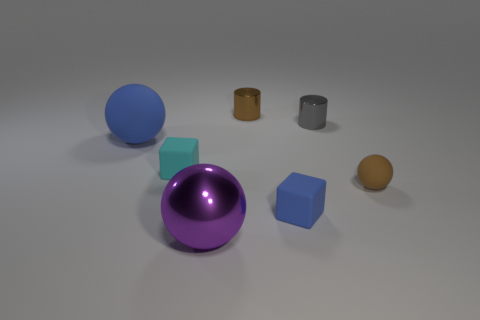What is the shape of the tiny thing in front of the ball that is on the right side of the gray metal cylinder?
Provide a short and direct response. Cube. What number of other things are the same shape as the large matte thing?
Offer a very short reply. 2. Are there any big purple shiny things right of the purple object?
Provide a succinct answer. No. What color is the big shiny sphere?
Keep it short and to the point. Purple. There is a big shiny ball; does it have the same color as the matte block left of the small blue matte cube?
Ensure brevity in your answer.  No. Are there any yellow rubber cubes that have the same size as the purple ball?
Give a very brief answer. No. There is a thing that is the same color as the big matte sphere; what is its size?
Provide a short and direct response. Small. There is a block behind the brown sphere; what is its material?
Your answer should be very brief. Rubber. Are there the same number of small matte spheres that are behind the blue rubber sphere and blue rubber balls that are behind the gray metallic cylinder?
Offer a terse response. Yes. There is a sphere that is in front of the tiny brown rubber sphere; does it have the same size as the rubber sphere that is to the right of the large shiny object?
Your response must be concise. No. 